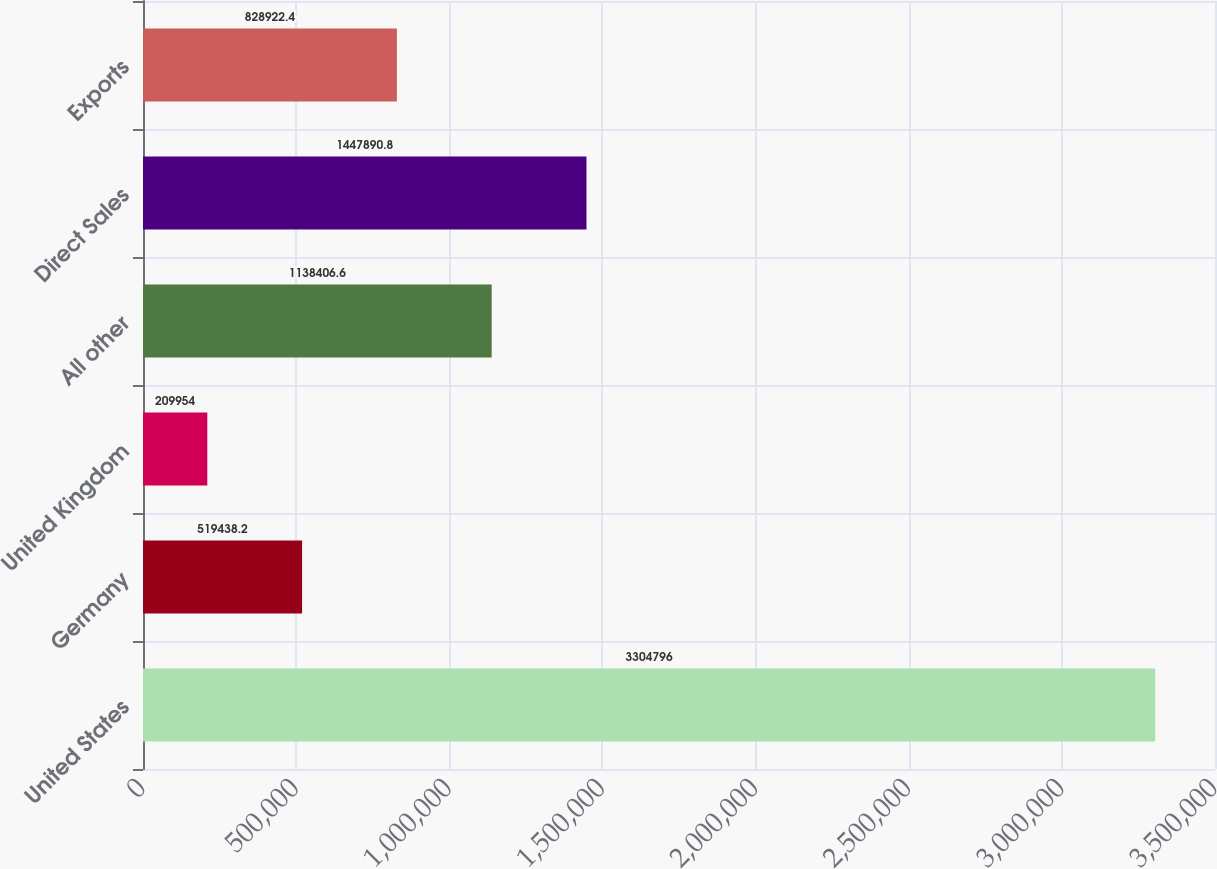<chart> <loc_0><loc_0><loc_500><loc_500><bar_chart><fcel>United States<fcel>Germany<fcel>United Kingdom<fcel>All other<fcel>Direct Sales<fcel>Exports<nl><fcel>3.3048e+06<fcel>519438<fcel>209954<fcel>1.13841e+06<fcel>1.44789e+06<fcel>828922<nl></chart> 